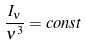Convert formula to latex. <formula><loc_0><loc_0><loc_500><loc_500>\frac { I _ { \nu } } { \nu ^ { 3 } } = c o n s t</formula> 